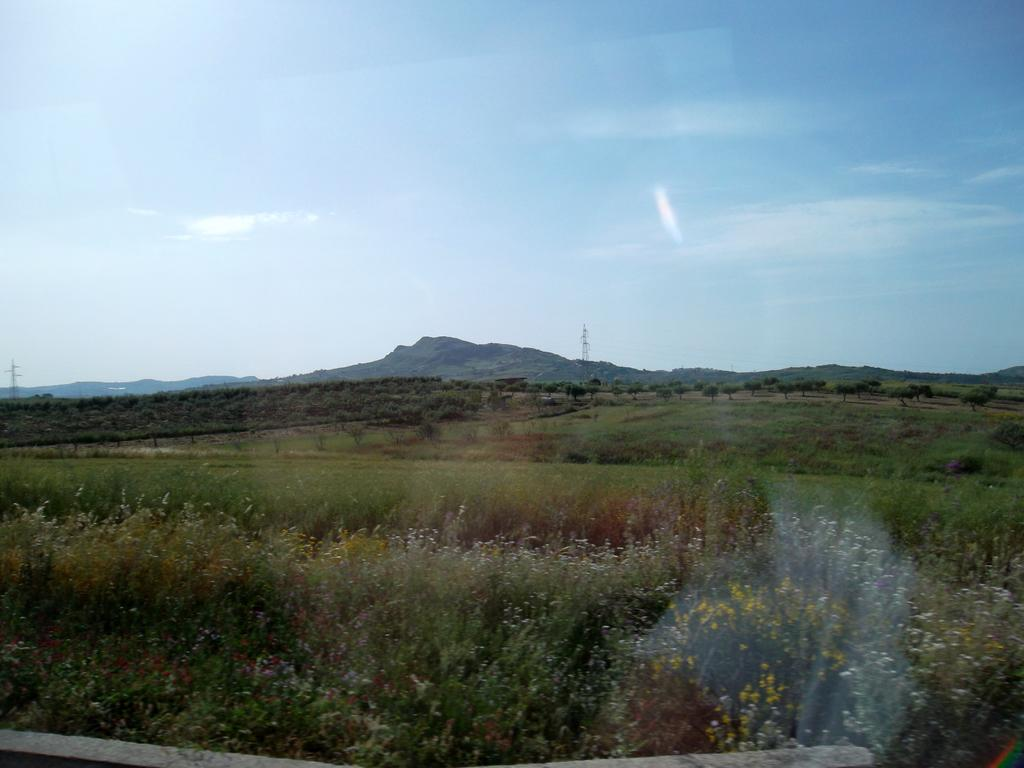What type of surface is visible in the image? There is grass on the surface in the image. What structures can be seen in the background of the image? There are towers in the background of the image. What type of vegetation is present in the background of the image? There are trees in the background of the image. What natural features can be seen in the background of the image? There are mountains in the background of the image. What is visible above the structures and vegetation in the image? The sky is visible in the background of the image. What type of loaf is being used to create pleasure in the image? There is no loaf or indication of pleasure in the image; it features grass, towers, trees, mountains, and the sky. 